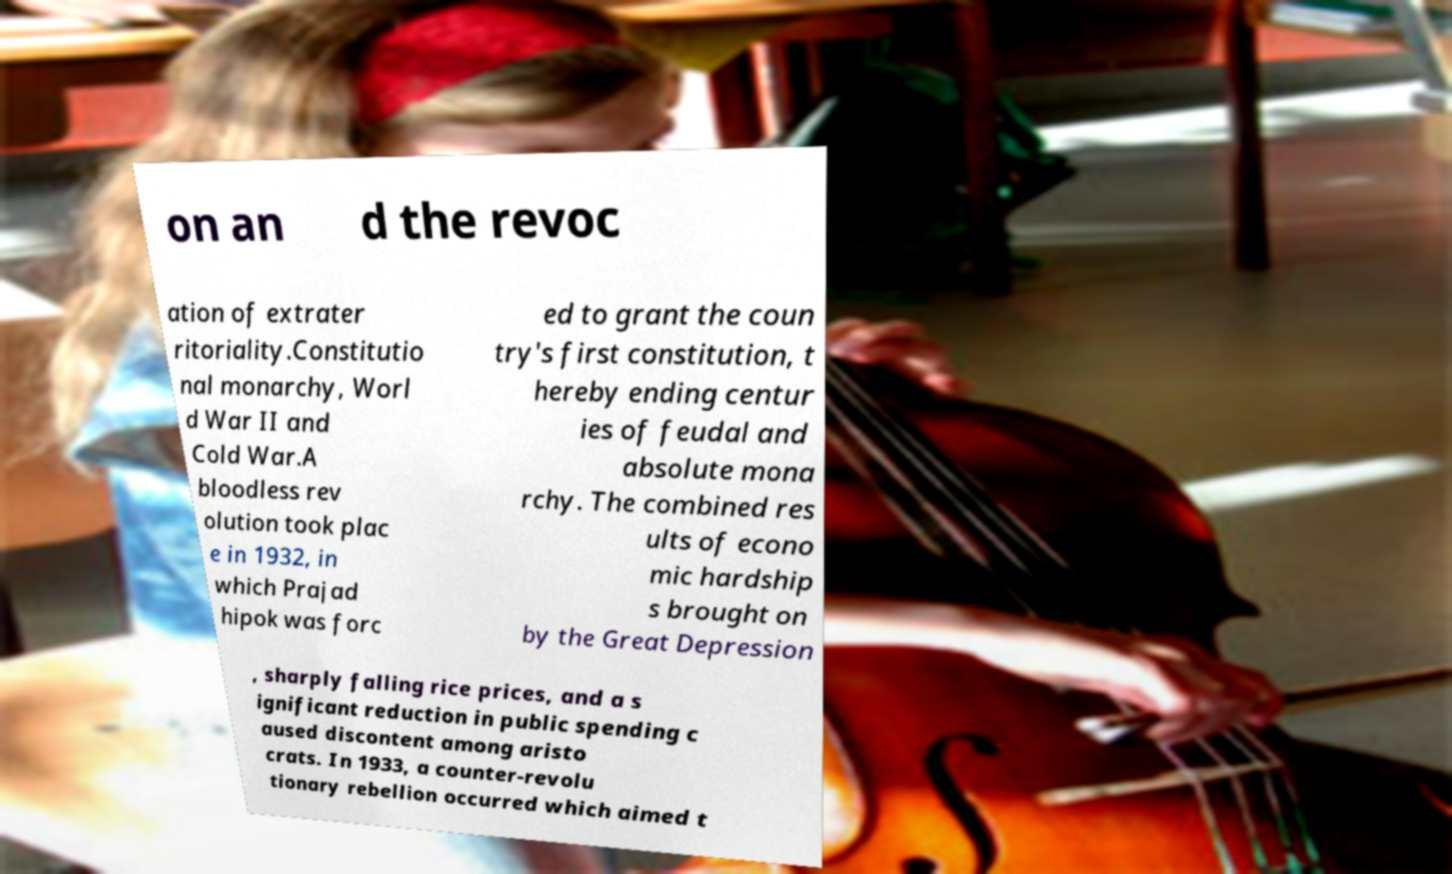What messages or text are displayed in this image? I need them in a readable, typed format. on an d the revoc ation of extrater ritoriality.Constitutio nal monarchy, Worl d War II and Cold War.A bloodless rev olution took plac e in 1932, in which Prajad hipok was forc ed to grant the coun try's first constitution, t hereby ending centur ies of feudal and absolute mona rchy. The combined res ults of econo mic hardship s brought on by the Great Depression , sharply falling rice prices, and a s ignificant reduction in public spending c aused discontent among aristo crats. In 1933, a counter-revolu tionary rebellion occurred which aimed t 